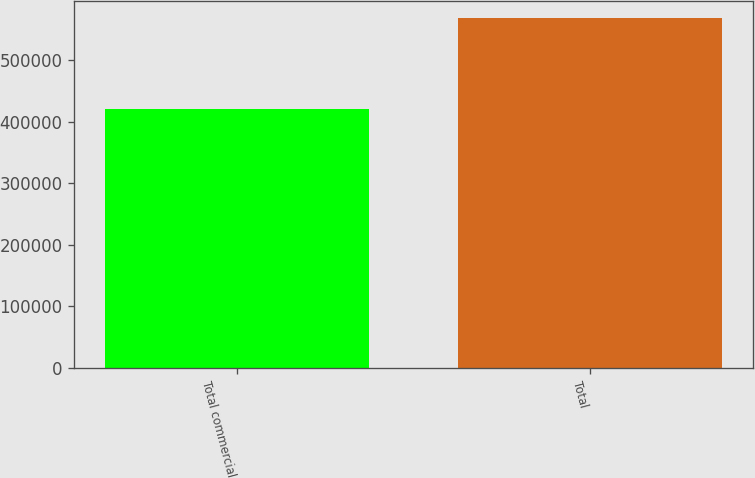Convert chart. <chart><loc_0><loc_0><loc_500><loc_500><bar_chart><fcel>Total commercial<fcel>Total<nl><fcel>420720<fcel>567522<nl></chart> 